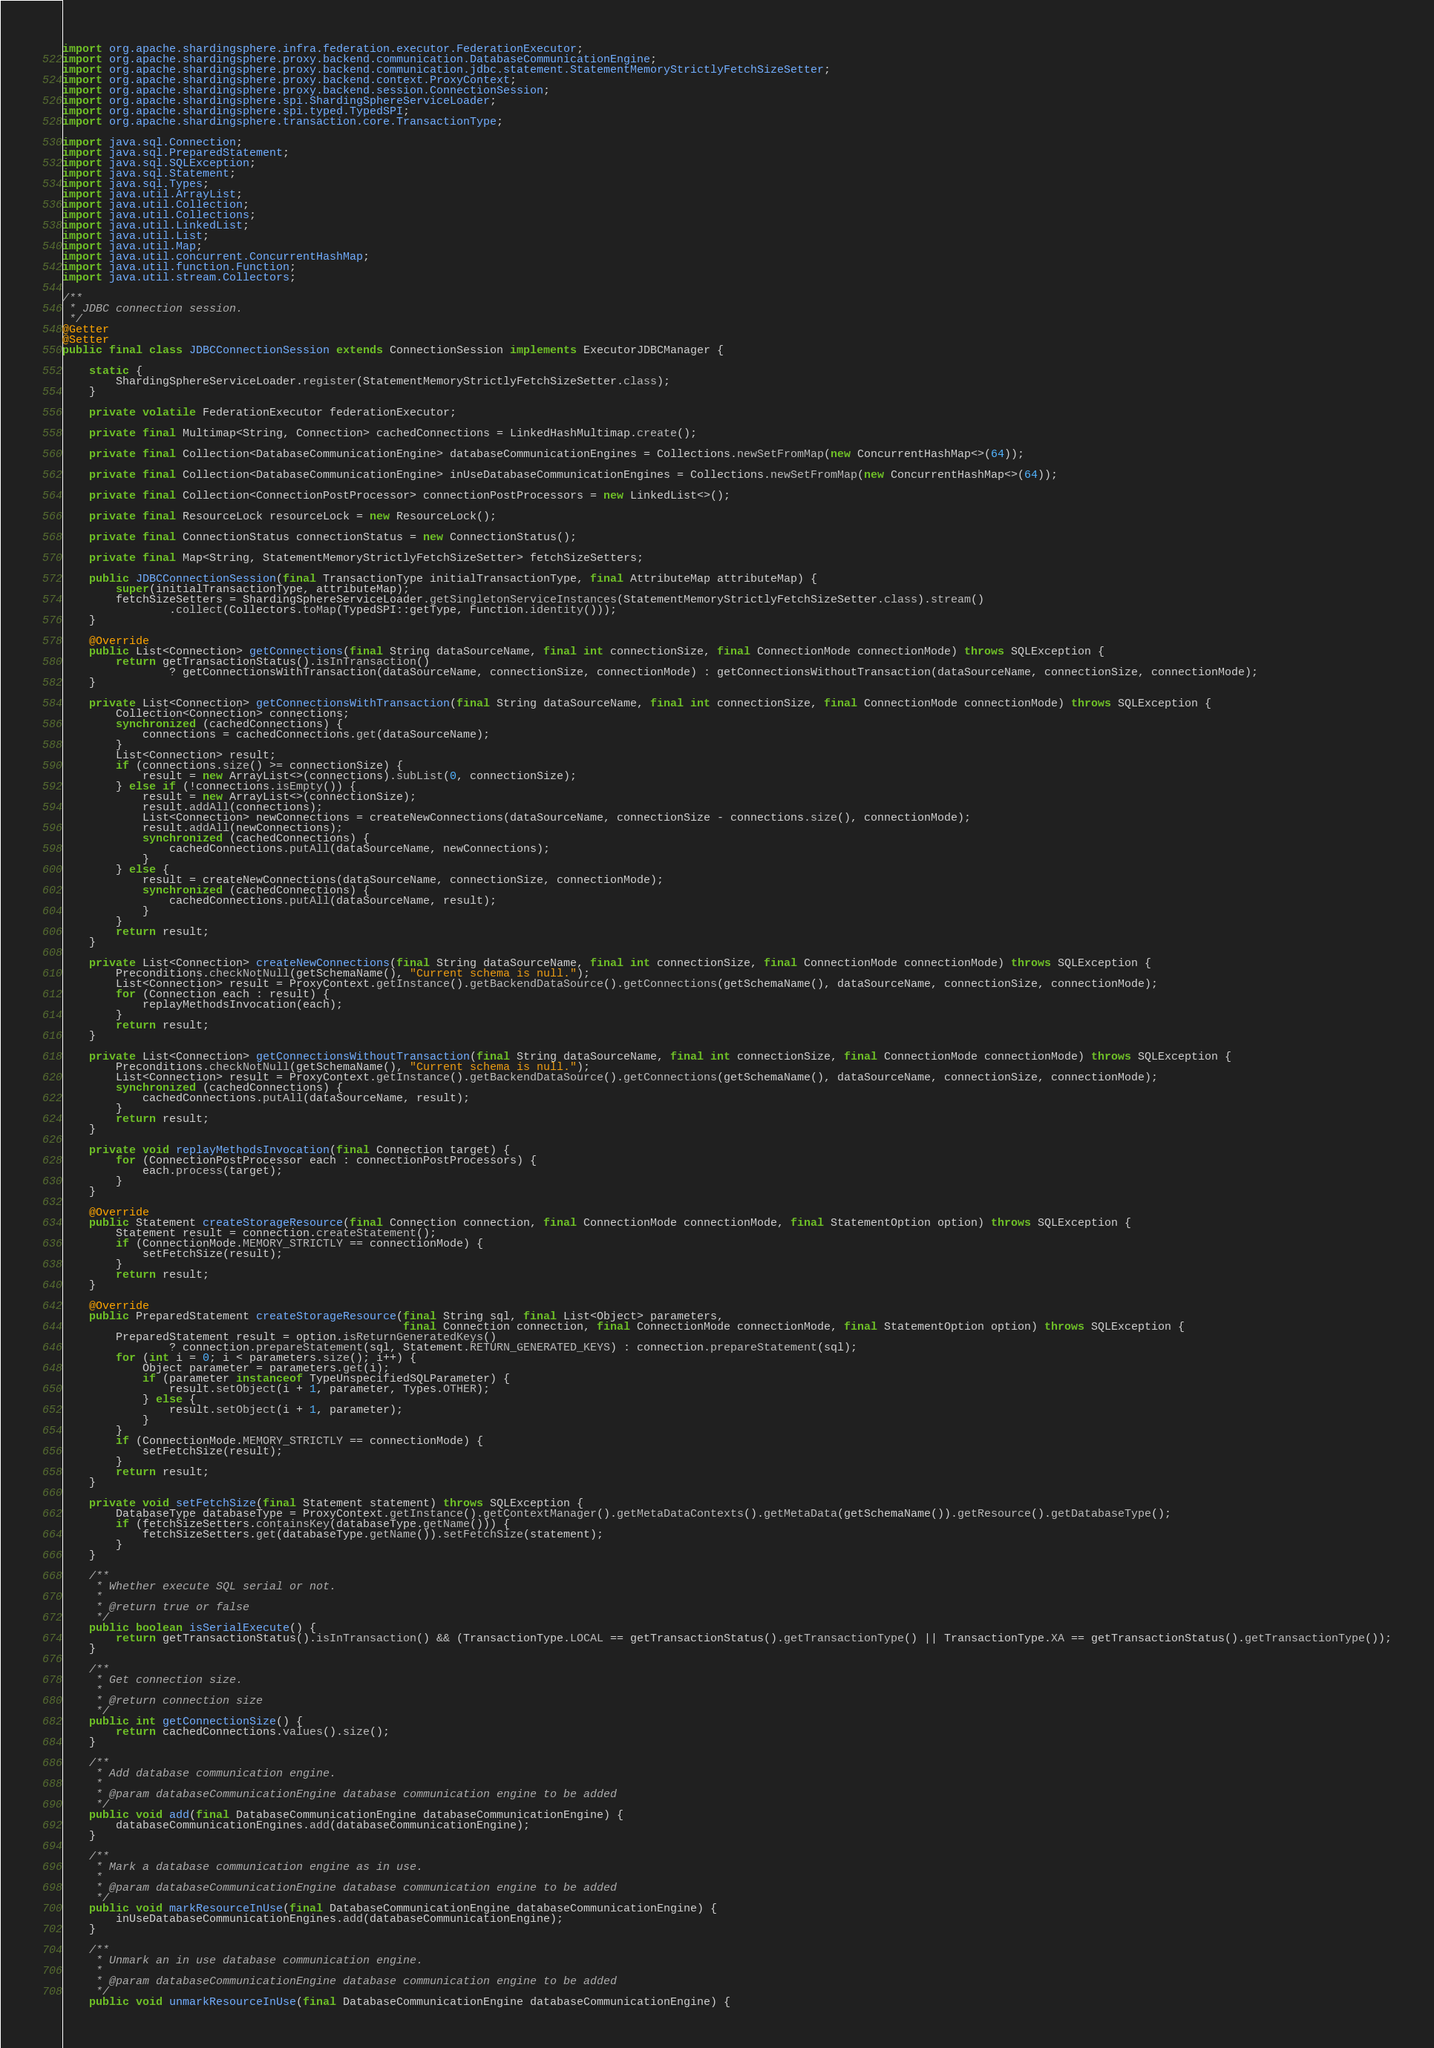Convert code to text. <code><loc_0><loc_0><loc_500><loc_500><_Java_>import org.apache.shardingsphere.infra.federation.executor.FederationExecutor;
import org.apache.shardingsphere.proxy.backend.communication.DatabaseCommunicationEngine;
import org.apache.shardingsphere.proxy.backend.communication.jdbc.statement.StatementMemoryStrictlyFetchSizeSetter;
import org.apache.shardingsphere.proxy.backend.context.ProxyContext;
import org.apache.shardingsphere.proxy.backend.session.ConnectionSession;
import org.apache.shardingsphere.spi.ShardingSphereServiceLoader;
import org.apache.shardingsphere.spi.typed.TypedSPI;
import org.apache.shardingsphere.transaction.core.TransactionType;

import java.sql.Connection;
import java.sql.PreparedStatement;
import java.sql.SQLException;
import java.sql.Statement;
import java.sql.Types;
import java.util.ArrayList;
import java.util.Collection;
import java.util.Collections;
import java.util.LinkedList;
import java.util.List;
import java.util.Map;
import java.util.concurrent.ConcurrentHashMap;
import java.util.function.Function;
import java.util.stream.Collectors;

/**
 * JDBC connection session.
 */
@Getter
@Setter
public final class JDBCConnectionSession extends ConnectionSession implements ExecutorJDBCManager {
    
    static {
        ShardingSphereServiceLoader.register(StatementMemoryStrictlyFetchSizeSetter.class);
    }
    
    private volatile FederationExecutor federationExecutor;
    
    private final Multimap<String, Connection> cachedConnections = LinkedHashMultimap.create();
    
    private final Collection<DatabaseCommunicationEngine> databaseCommunicationEngines = Collections.newSetFromMap(new ConcurrentHashMap<>(64));
    
    private final Collection<DatabaseCommunicationEngine> inUseDatabaseCommunicationEngines = Collections.newSetFromMap(new ConcurrentHashMap<>(64));
    
    private final Collection<ConnectionPostProcessor> connectionPostProcessors = new LinkedList<>();
    
    private final ResourceLock resourceLock = new ResourceLock();
    
    private final ConnectionStatus connectionStatus = new ConnectionStatus();
    
    private final Map<String, StatementMemoryStrictlyFetchSizeSetter> fetchSizeSetters;
    
    public JDBCConnectionSession(final TransactionType initialTransactionType, final AttributeMap attributeMap) {
        super(initialTransactionType, attributeMap);
        fetchSizeSetters = ShardingSphereServiceLoader.getSingletonServiceInstances(StatementMemoryStrictlyFetchSizeSetter.class).stream()
                .collect(Collectors.toMap(TypedSPI::getType, Function.identity()));
    }
    
    @Override
    public List<Connection> getConnections(final String dataSourceName, final int connectionSize, final ConnectionMode connectionMode) throws SQLException {
        return getTransactionStatus().isInTransaction()
                ? getConnectionsWithTransaction(dataSourceName, connectionSize, connectionMode) : getConnectionsWithoutTransaction(dataSourceName, connectionSize, connectionMode);
    }
    
    private List<Connection> getConnectionsWithTransaction(final String dataSourceName, final int connectionSize, final ConnectionMode connectionMode) throws SQLException {
        Collection<Connection> connections;
        synchronized (cachedConnections) {
            connections = cachedConnections.get(dataSourceName);
        }
        List<Connection> result;
        if (connections.size() >= connectionSize) {
            result = new ArrayList<>(connections).subList(0, connectionSize);
        } else if (!connections.isEmpty()) {
            result = new ArrayList<>(connectionSize);
            result.addAll(connections);
            List<Connection> newConnections = createNewConnections(dataSourceName, connectionSize - connections.size(), connectionMode);
            result.addAll(newConnections);
            synchronized (cachedConnections) {
                cachedConnections.putAll(dataSourceName, newConnections);
            }
        } else {
            result = createNewConnections(dataSourceName, connectionSize, connectionMode);
            synchronized (cachedConnections) {
                cachedConnections.putAll(dataSourceName, result);
            }
        }
        return result;
    }
    
    private List<Connection> createNewConnections(final String dataSourceName, final int connectionSize, final ConnectionMode connectionMode) throws SQLException {
        Preconditions.checkNotNull(getSchemaName(), "Current schema is null.");
        List<Connection> result = ProxyContext.getInstance().getBackendDataSource().getConnections(getSchemaName(), dataSourceName, connectionSize, connectionMode);
        for (Connection each : result) {
            replayMethodsInvocation(each);
        }
        return result;
    }
    
    private List<Connection> getConnectionsWithoutTransaction(final String dataSourceName, final int connectionSize, final ConnectionMode connectionMode) throws SQLException {
        Preconditions.checkNotNull(getSchemaName(), "Current schema is null.");
        List<Connection> result = ProxyContext.getInstance().getBackendDataSource().getConnections(getSchemaName(), dataSourceName, connectionSize, connectionMode);
        synchronized (cachedConnections) {
            cachedConnections.putAll(dataSourceName, result);
        }
        return result;
    }
    
    private void replayMethodsInvocation(final Connection target) {
        for (ConnectionPostProcessor each : connectionPostProcessors) {
            each.process(target);
        }
    }
    
    @Override
    public Statement createStorageResource(final Connection connection, final ConnectionMode connectionMode, final StatementOption option) throws SQLException {
        Statement result = connection.createStatement();
        if (ConnectionMode.MEMORY_STRICTLY == connectionMode) {
            setFetchSize(result);
        }
        return result;
    }
    
    @Override
    public PreparedStatement createStorageResource(final String sql, final List<Object> parameters, 
                                                   final Connection connection, final ConnectionMode connectionMode, final StatementOption option) throws SQLException {
        PreparedStatement result = option.isReturnGeneratedKeys()
                ? connection.prepareStatement(sql, Statement.RETURN_GENERATED_KEYS) : connection.prepareStatement(sql);
        for (int i = 0; i < parameters.size(); i++) {
            Object parameter = parameters.get(i);
            if (parameter instanceof TypeUnspecifiedSQLParameter) {
                result.setObject(i + 1, parameter, Types.OTHER);
            } else {
                result.setObject(i + 1, parameter);
            }
        }
        if (ConnectionMode.MEMORY_STRICTLY == connectionMode) {
            setFetchSize(result);
        }
        return result;
    }
    
    private void setFetchSize(final Statement statement) throws SQLException {
        DatabaseType databaseType = ProxyContext.getInstance().getContextManager().getMetaDataContexts().getMetaData(getSchemaName()).getResource().getDatabaseType();
        if (fetchSizeSetters.containsKey(databaseType.getName())) {
            fetchSizeSetters.get(databaseType.getName()).setFetchSize(statement);
        }
    }
    
    /**
     * Whether execute SQL serial or not.
     *
     * @return true or false
     */
    public boolean isSerialExecute() {
        return getTransactionStatus().isInTransaction() && (TransactionType.LOCAL == getTransactionStatus().getTransactionType() || TransactionType.XA == getTransactionStatus().getTransactionType());
    }
    
    /**
     * Get connection size.
     *
     * @return connection size
     */
    public int getConnectionSize() {
        return cachedConnections.values().size();
    }
    
    /**
     * Add database communication engine.
     *
     * @param databaseCommunicationEngine database communication engine to be added
     */
    public void add(final DatabaseCommunicationEngine databaseCommunicationEngine) {
        databaseCommunicationEngines.add(databaseCommunicationEngine);
    }
    
    /**
     * Mark a database communication engine as in use.
     *
     * @param databaseCommunicationEngine database communication engine to be added
     */
    public void markResourceInUse(final DatabaseCommunicationEngine databaseCommunicationEngine) {
        inUseDatabaseCommunicationEngines.add(databaseCommunicationEngine);
    }
    
    /**
     * Unmark an in use database communication engine.
     *
     * @param databaseCommunicationEngine database communication engine to be added
     */
    public void unmarkResourceInUse(final DatabaseCommunicationEngine databaseCommunicationEngine) {</code> 